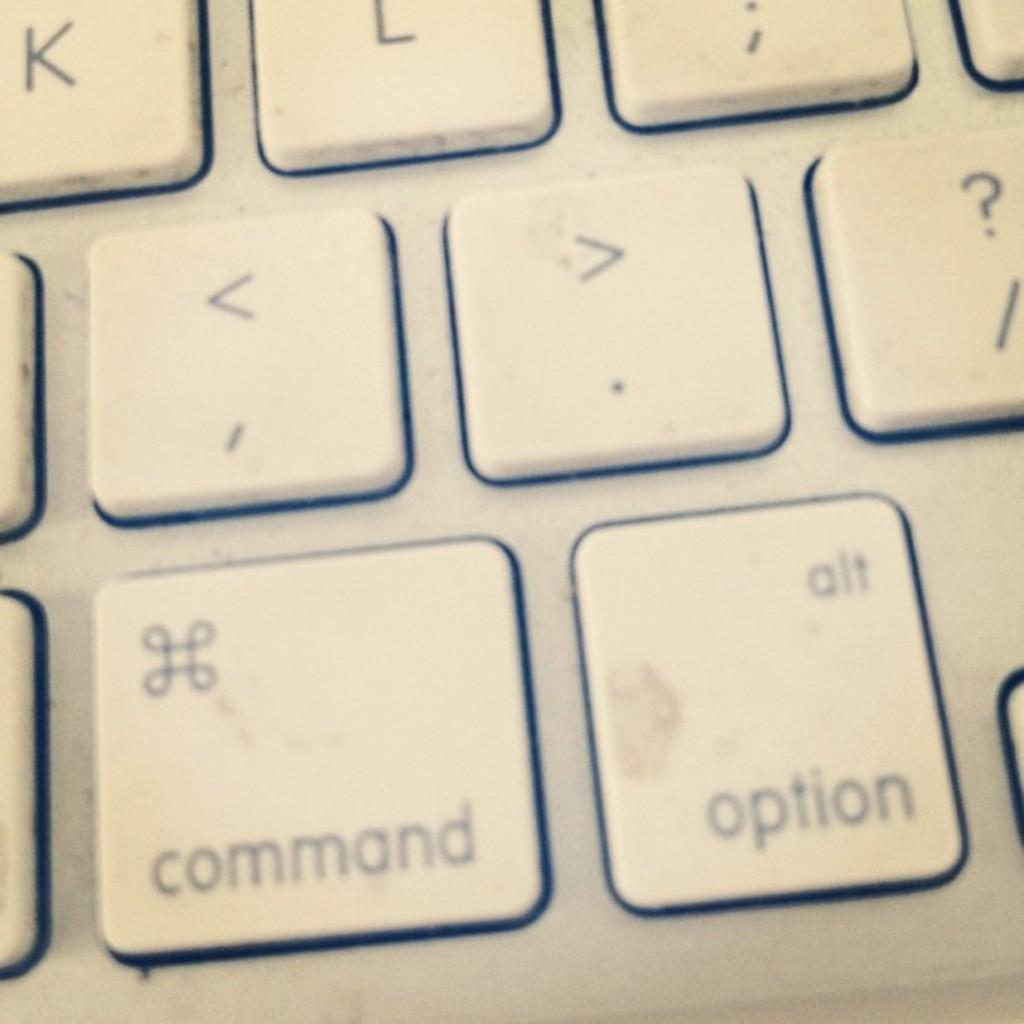What function does the bottom left key perform?
Keep it short and to the point. Command. What is printed above the word option on the same key?
Ensure brevity in your answer.  Alt. 